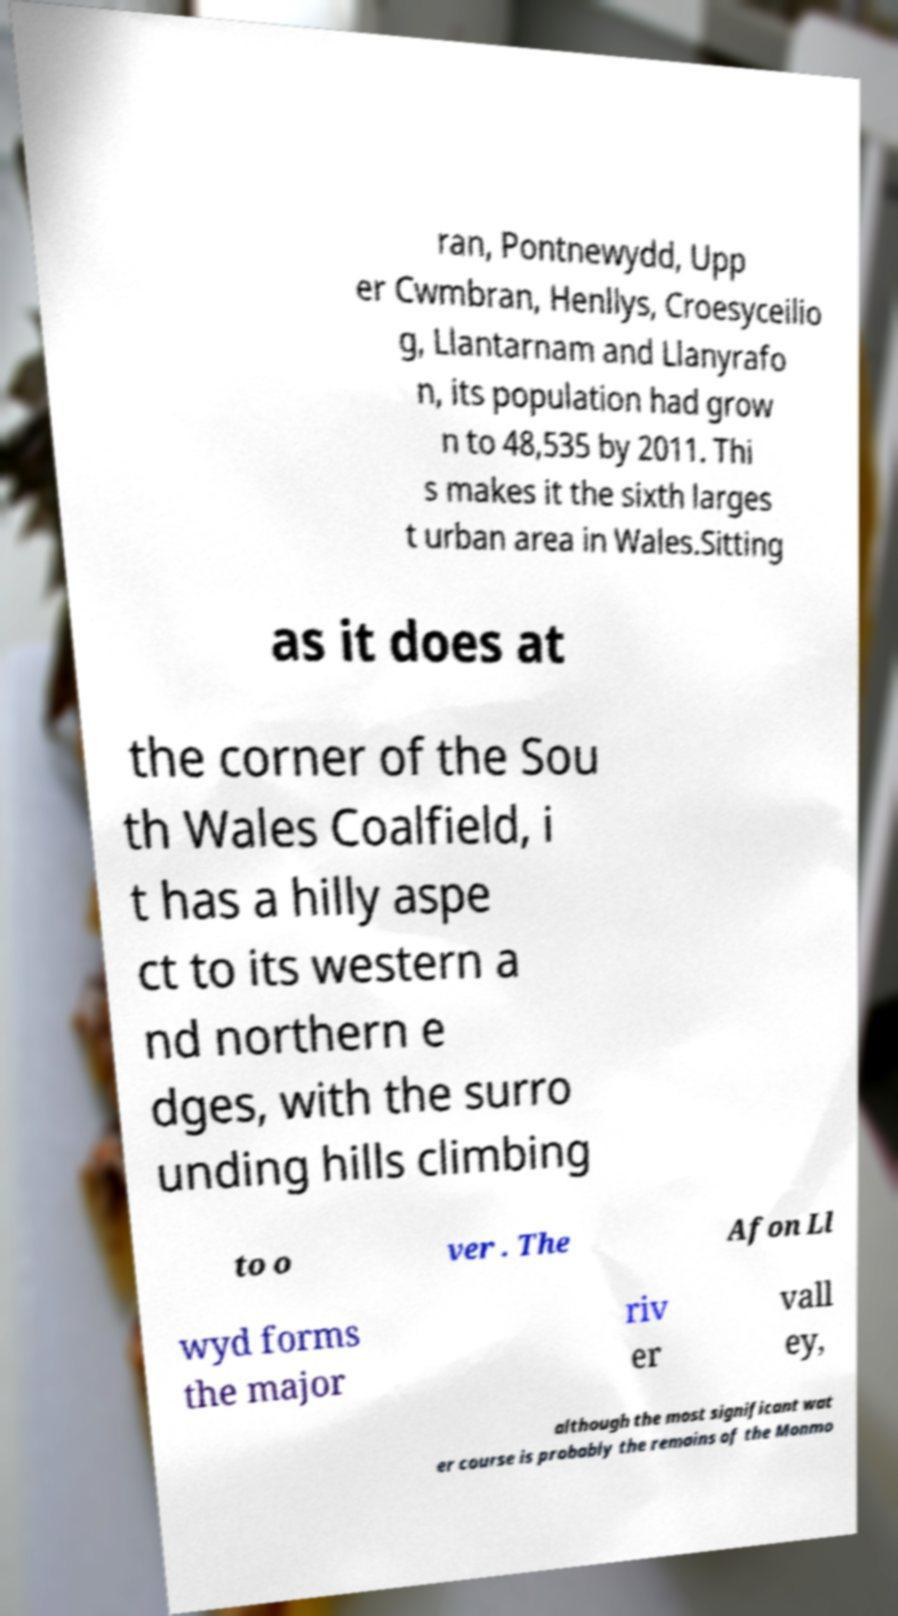Please identify and transcribe the text found in this image. ran, Pontnewydd, Upp er Cwmbran, Henllys, Croesyceilio g, Llantarnam and Llanyrafo n, its population had grow n to 48,535 by 2011. Thi s makes it the sixth larges t urban area in Wales.Sitting as it does at the corner of the Sou th Wales Coalfield, i t has a hilly aspe ct to its western a nd northern e dges, with the surro unding hills climbing to o ver . The Afon Ll wyd forms the major riv er vall ey, although the most significant wat er course is probably the remains of the Monmo 